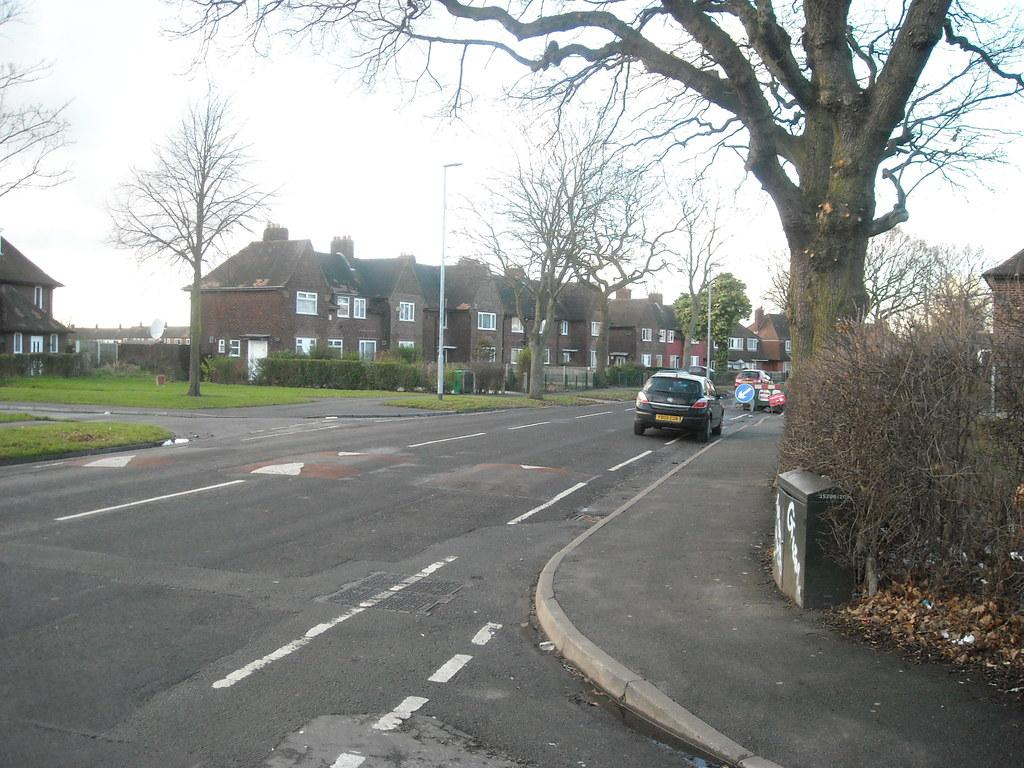What can be seen moving on the road in the image? There are vehicles on the road in the image. What type of information might be conveyed by the sign boards in the image? The sign boards in the image might convey information about directions, warnings, or advertisements. What architectural feature can be seen in the houses in the image? The houses in the image have windows. What type of vegetation is visible in the image? Plants and trees are visible in the image. What design can be seen on the trees in the image? There is no specific design on the trees in the image; they are natural vegetation. What thing is being used to measure the height of the trees in the image? There is no measuring device or activity visible in the image; it only shows trees, plants, houses, vehicles, and sign boards. 